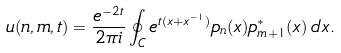Convert formula to latex. <formula><loc_0><loc_0><loc_500><loc_500>u ( n , m , t ) = \frac { e ^ { - 2 t } } { 2 \pi i } \oint _ { C } e ^ { t ( x + x ^ { - 1 } ) } p _ { n } ( x ) p ^ { * } _ { m + 1 } ( x ) \, d x .</formula> 